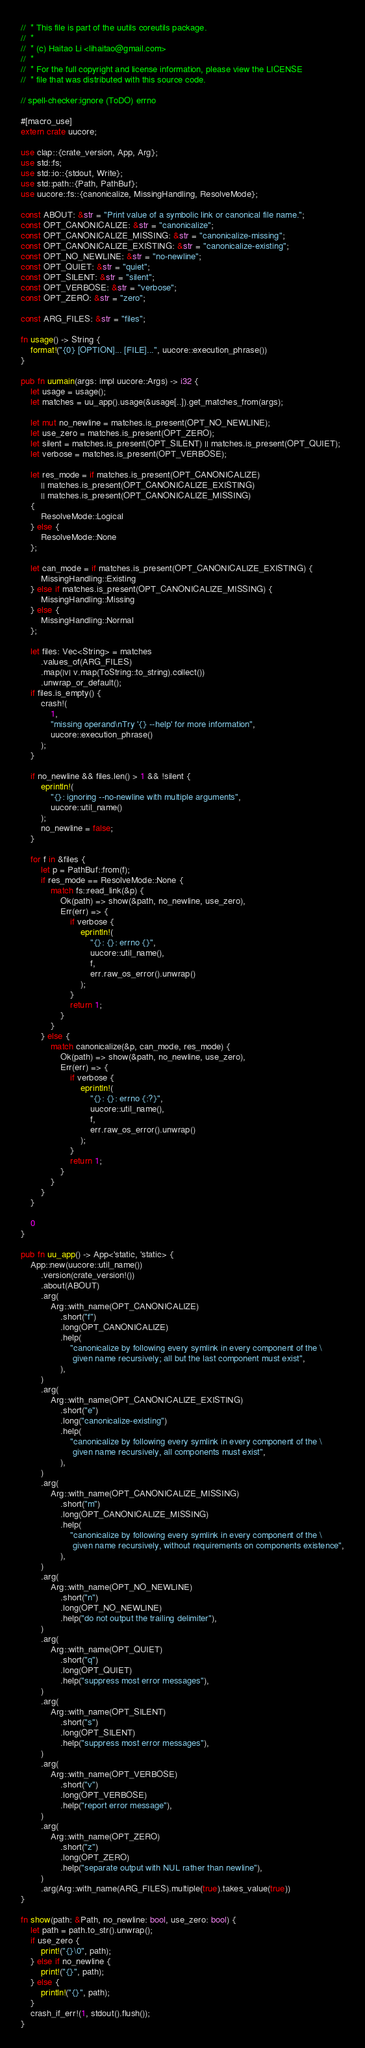Convert code to text. <code><loc_0><loc_0><loc_500><loc_500><_Rust_>//  * This file is part of the uutils coreutils package.
//  *
//  * (c) Haitao Li <lihaitao@gmail.com>
//  *
//  * For the full copyright and license information, please view the LICENSE
//  * file that was distributed with this source code.

// spell-checker:ignore (ToDO) errno

#[macro_use]
extern crate uucore;

use clap::{crate_version, App, Arg};
use std::fs;
use std::io::{stdout, Write};
use std::path::{Path, PathBuf};
use uucore::fs::{canonicalize, MissingHandling, ResolveMode};

const ABOUT: &str = "Print value of a symbolic link or canonical file name.";
const OPT_CANONICALIZE: &str = "canonicalize";
const OPT_CANONICALIZE_MISSING: &str = "canonicalize-missing";
const OPT_CANONICALIZE_EXISTING: &str = "canonicalize-existing";
const OPT_NO_NEWLINE: &str = "no-newline";
const OPT_QUIET: &str = "quiet";
const OPT_SILENT: &str = "silent";
const OPT_VERBOSE: &str = "verbose";
const OPT_ZERO: &str = "zero";

const ARG_FILES: &str = "files";

fn usage() -> String {
    format!("{0} [OPTION]... [FILE]...", uucore::execution_phrase())
}

pub fn uumain(args: impl uucore::Args) -> i32 {
    let usage = usage();
    let matches = uu_app().usage(&usage[..]).get_matches_from(args);

    let mut no_newline = matches.is_present(OPT_NO_NEWLINE);
    let use_zero = matches.is_present(OPT_ZERO);
    let silent = matches.is_present(OPT_SILENT) || matches.is_present(OPT_QUIET);
    let verbose = matches.is_present(OPT_VERBOSE);

    let res_mode = if matches.is_present(OPT_CANONICALIZE)
        || matches.is_present(OPT_CANONICALIZE_EXISTING)
        || matches.is_present(OPT_CANONICALIZE_MISSING)
    {
        ResolveMode::Logical
    } else {
        ResolveMode::None
    };

    let can_mode = if matches.is_present(OPT_CANONICALIZE_EXISTING) {
        MissingHandling::Existing
    } else if matches.is_present(OPT_CANONICALIZE_MISSING) {
        MissingHandling::Missing
    } else {
        MissingHandling::Normal
    };

    let files: Vec<String> = matches
        .values_of(ARG_FILES)
        .map(|v| v.map(ToString::to_string).collect())
        .unwrap_or_default();
    if files.is_empty() {
        crash!(
            1,
            "missing operand\nTry '{} --help' for more information",
            uucore::execution_phrase()
        );
    }

    if no_newline && files.len() > 1 && !silent {
        eprintln!(
            "{}: ignoring --no-newline with multiple arguments",
            uucore::util_name()
        );
        no_newline = false;
    }

    for f in &files {
        let p = PathBuf::from(f);
        if res_mode == ResolveMode::None {
            match fs::read_link(&p) {
                Ok(path) => show(&path, no_newline, use_zero),
                Err(err) => {
                    if verbose {
                        eprintln!(
                            "{}: {}: errno {}",
                            uucore::util_name(),
                            f,
                            err.raw_os_error().unwrap()
                        );
                    }
                    return 1;
                }
            }
        } else {
            match canonicalize(&p, can_mode, res_mode) {
                Ok(path) => show(&path, no_newline, use_zero),
                Err(err) => {
                    if verbose {
                        eprintln!(
                            "{}: {}: errno {:?}",
                            uucore::util_name(),
                            f,
                            err.raw_os_error().unwrap()
                        );
                    }
                    return 1;
                }
            }
        }
    }

    0
}

pub fn uu_app() -> App<'static, 'static> {
    App::new(uucore::util_name())
        .version(crate_version!())
        .about(ABOUT)
        .arg(
            Arg::with_name(OPT_CANONICALIZE)
                .short("f")
                .long(OPT_CANONICALIZE)
                .help(
                    "canonicalize by following every symlink in every component of the \
                     given name recursively; all but the last component must exist",
                ),
        )
        .arg(
            Arg::with_name(OPT_CANONICALIZE_EXISTING)
                .short("e")
                .long("canonicalize-existing")
                .help(
                    "canonicalize by following every symlink in every component of the \
                     given name recursively, all components must exist",
                ),
        )
        .arg(
            Arg::with_name(OPT_CANONICALIZE_MISSING)
                .short("m")
                .long(OPT_CANONICALIZE_MISSING)
                .help(
                    "canonicalize by following every symlink in every component of the \
                     given name recursively, without requirements on components existence",
                ),
        )
        .arg(
            Arg::with_name(OPT_NO_NEWLINE)
                .short("n")
                .long(OPT_NO_NEWLINE)
                .help("do not output the trailing delimiter"),
        )
        .arg(
            Arg::with_name(OPT_QUIET)
                .short("q")
                .long(OPT_QUIET)
                .help("suppress most error messages"),
        )
        .arg(
            Arg::with_name(OPT_SILENT)
                .short("s")
                .long(OPT_SILENT)
                .help("suppress most error messages"),
        )
        .arg(
            Arg::with_name(OPT_VERBOSE)
                .short("v")
                .long(OPT_VERBOSE)
                .help("report error message"),
        )
        .arg(
            Arg::with_name(OPT_ZERO)
                .short("z")
                .long(OPT_ZERO)
                .help("separate output with NUL rather than newline"),
        )
        .arg(Arg::with_name(ARG_FILES).multiple(true).takes_value(true))
}

fn show(path: &Path, no_newline: bool, use_zero: bool) {
    let path = path.to_str().unwrap();
    if use_zero {
        print!("{}\0", path);
    } else if no_newline {
        print!("{}", path);
    } else {
        println!("{}", path);
    }
    crash_if_err!(1, stdout().flush());
}
</code> 